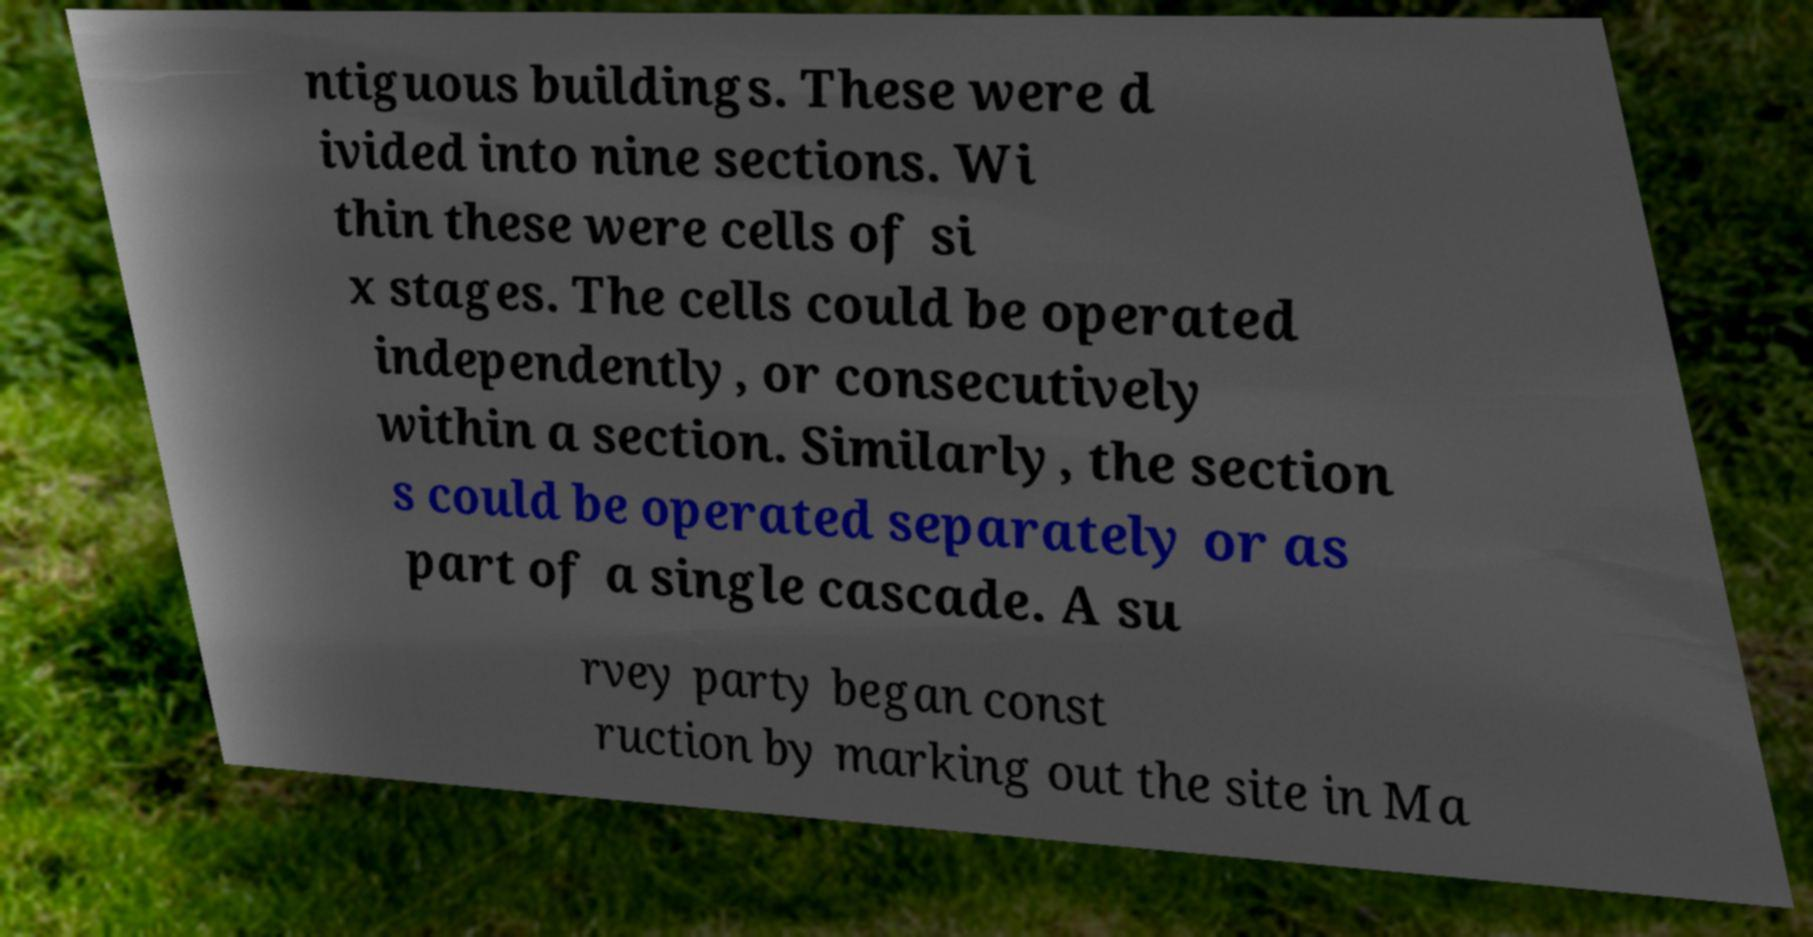Can you accurately transcribe the text from the provided image for me? ntiguous buildings. These were d ivided into nine sections. Wi thin these were cells of si x stages. The cells could be operated independently, or consecutively within a section. Similarly, the section s could be operated separately or as part of a single cascade. A su rvey party began const ruction by marking out the site in Ma 